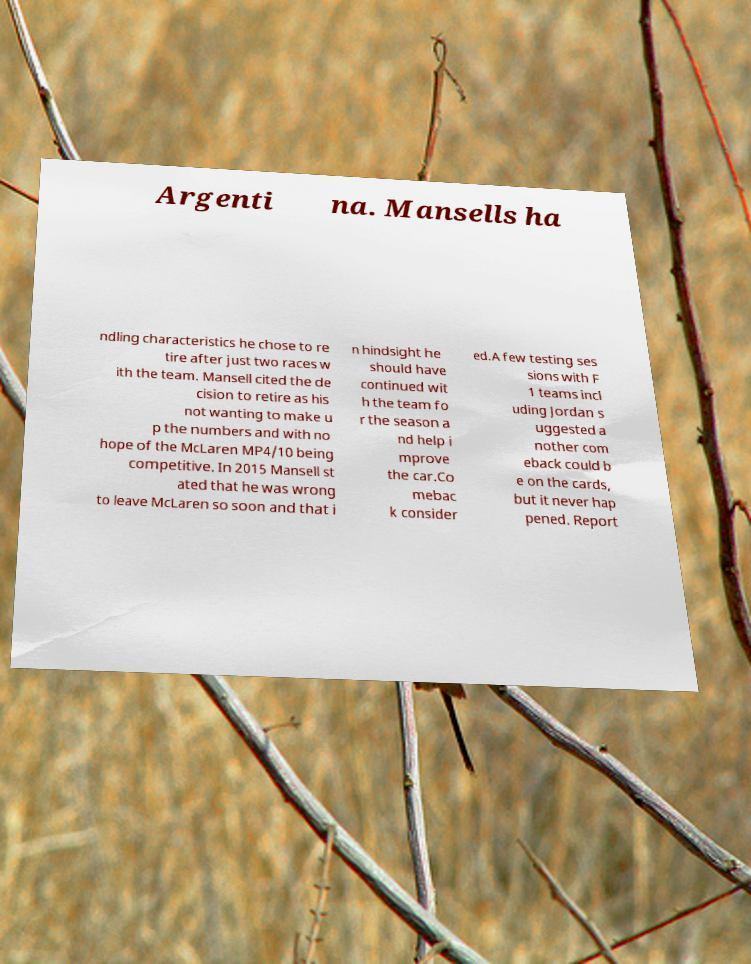There's text embedded in this image that I need extracted. Can you transcribe it verbatim? Argenti na. Mansells ha ndling characteristics he chose to re tire after just two races w ith the team. Mansell cited the de cision to retire as his not wanting to make u p the numbers and with no hope of the McLaren MP4/10 being competitive. In 2015 Mansell st ated that he was wrong to leave McLaren so soon and that i n hindsight he should have continued wit h the team fo r the season a nd help i mprove the car.Co mebac k consider ed.A few testing ses sions with F 1 teams incl uding Jordan s uggested a nother com eback could b e on the cards, but it never hap pened. Report 